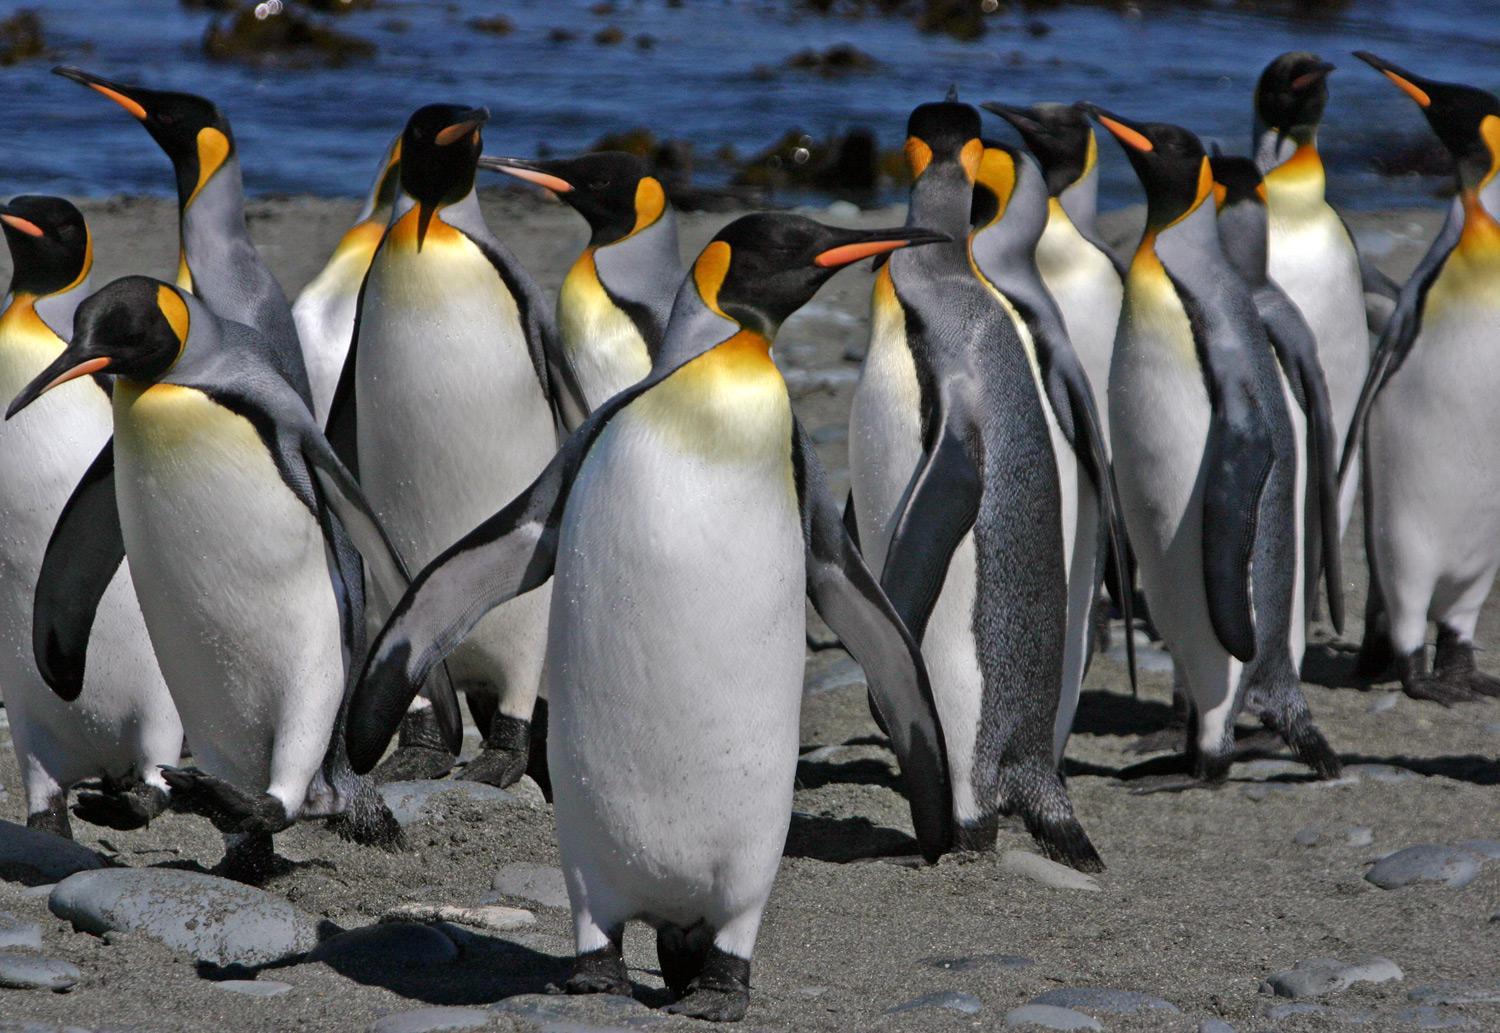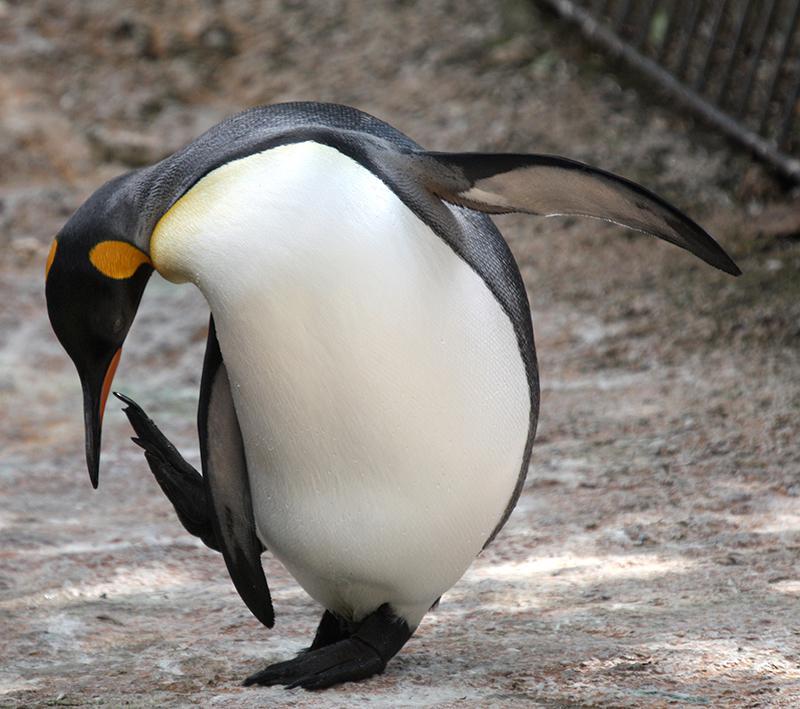The first image is the image on the left, the second image is the image on the right. Considering the images on both sides, is "There are five penguins" valid? Answer yes or no. No. The first image is the image on the left, the second image is the image on the right. Analyze the images presented: Is the assertion "In total, there are no more than five penguins pictured." valid? Answer yes or no. No. 